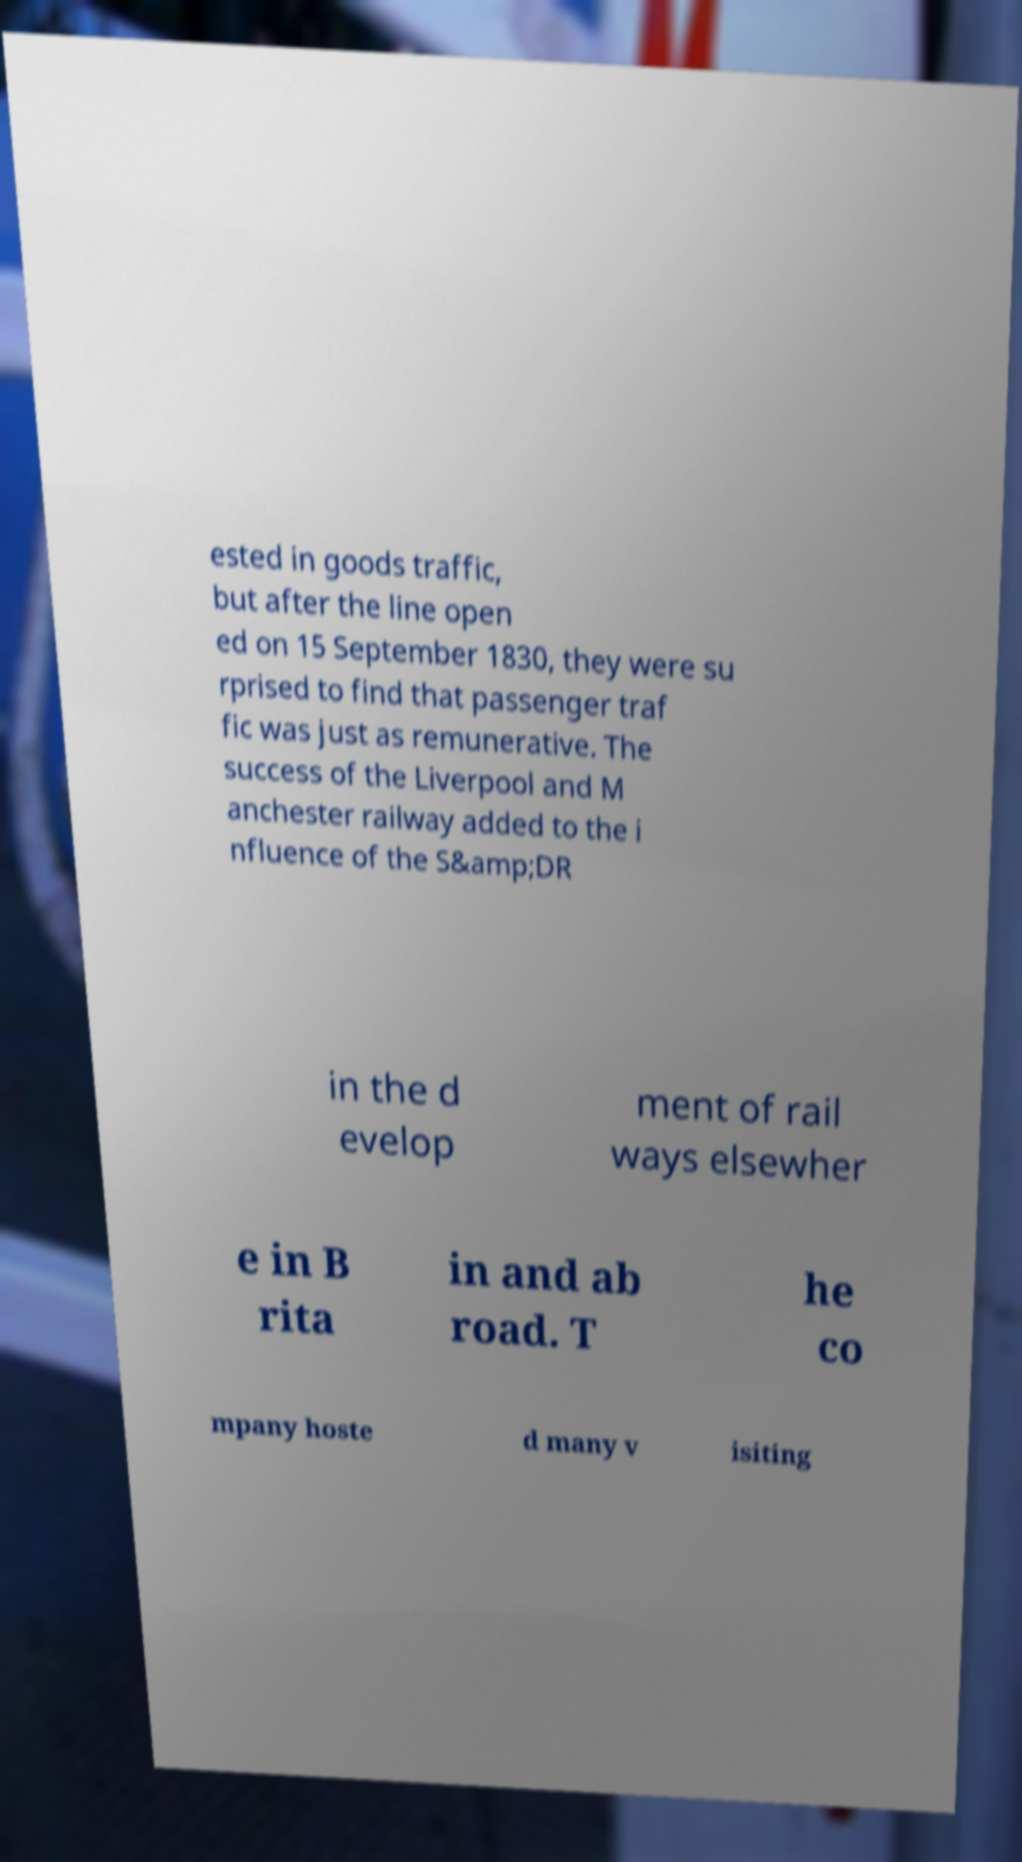I need the written content from this picture converted into text. Can you do that? ested in goods traffic, but after the line open ed on 15 September 1830, they were su rprised to find that passenger traf fic was just as remunerative. The success of the Liverpool and M anchester railway added to the i nfluence of the S&amp;DR in the d evelop ment of rail ways elsewher e in B rita in and ab road. T he co mpany hoste d many v isiting 